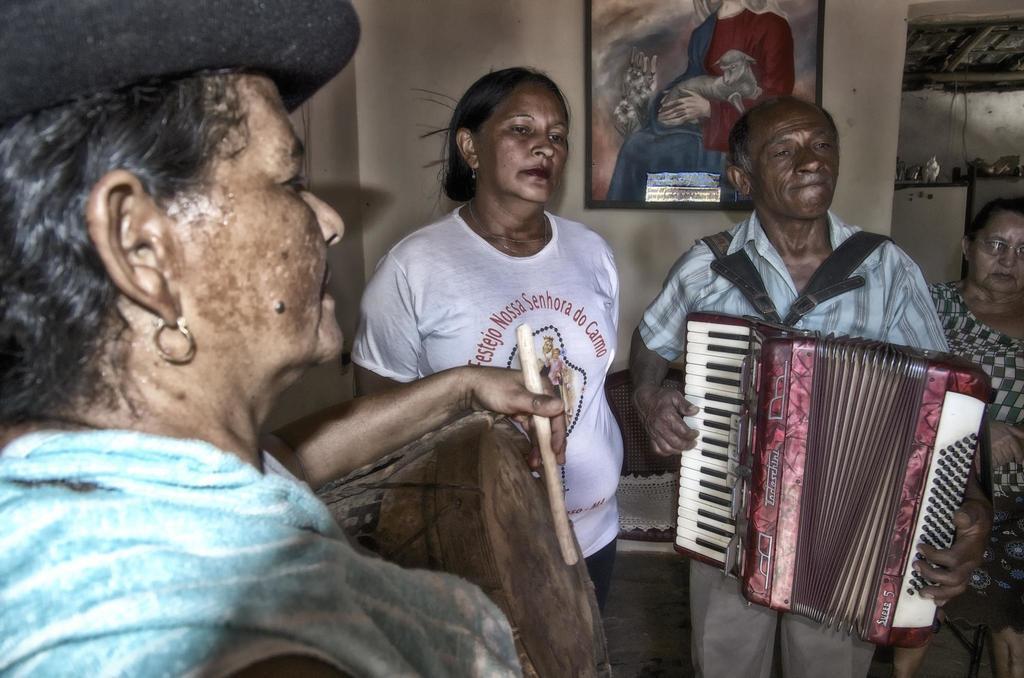Could you give a brief overview of what you see in this image? In this image I can see four people standing and wearing the different color dresses. I can see two people playing the musical instruments and one person wearing the cap. In the background I can see the frame to the wall. 